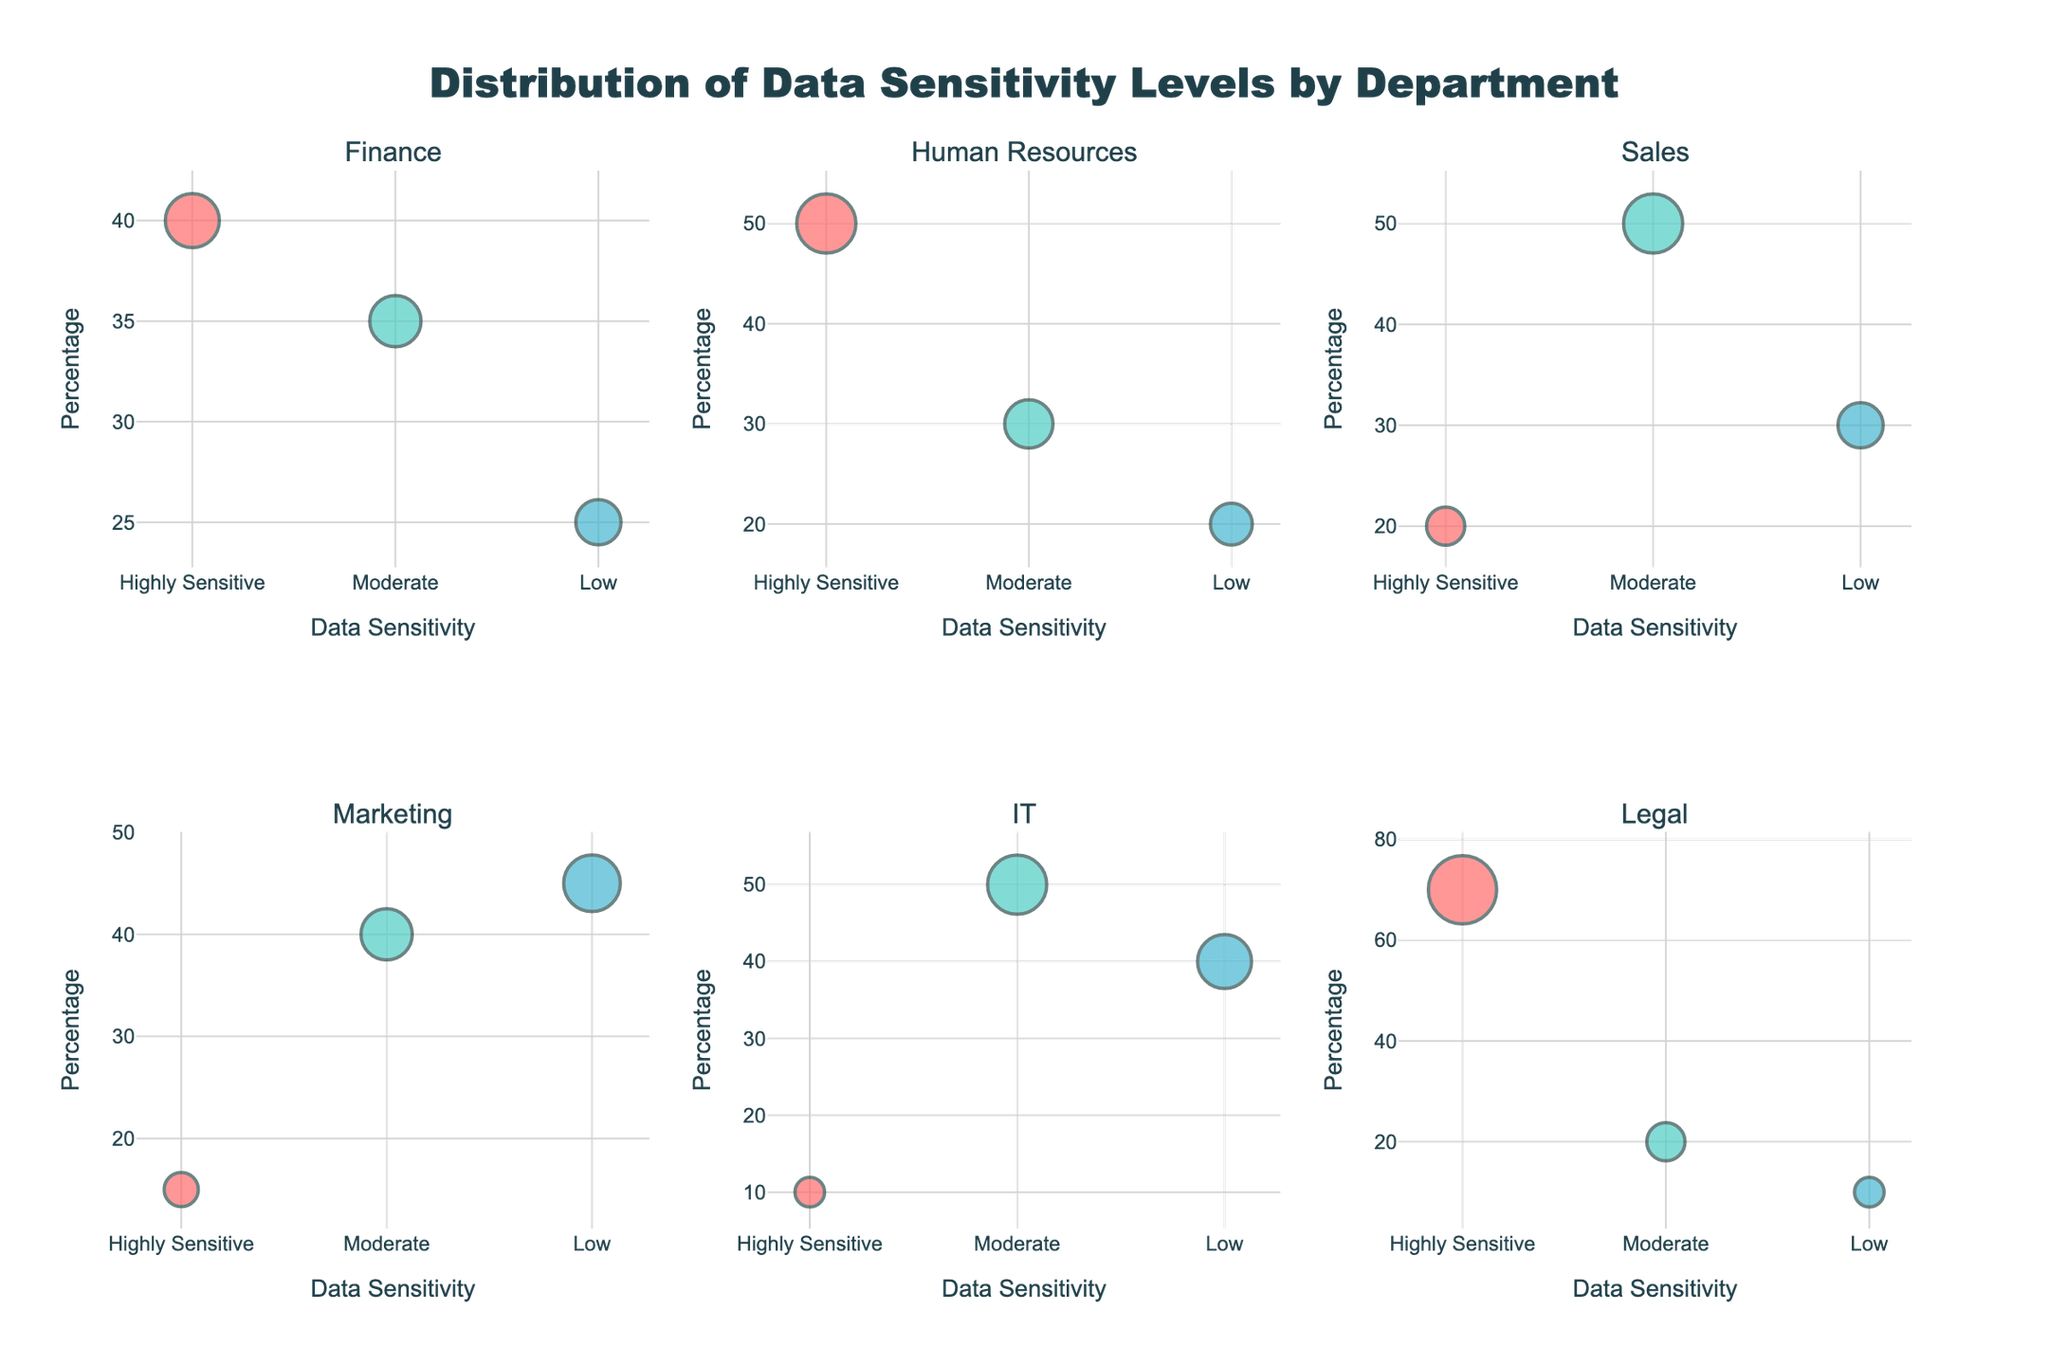What is the title of the figure? The title of the figure is displayed at the top and contains large text summarizing the subject matter.
Answer: "Distribution of Data Sensitivity Levels by Department" What is the color used for 'Highly Sensitive' data sensitivity levels? The color associated with 'Highly Sensitive' is the same across all departments and is visually distinct from other sensitivity levels.
Answer: Red Which department has the highest percentage of 'Highly Sensitive' data? Look at the department with the highest bubble in the 'Highly Sensitive' category on the y-axis.
Answer: Legal Which department has the lowest percentage of 'Highly Sensitive' data? Identifying the department with the lowest 'Highly Sensitive' bubble will show the correct department.
Answer: IT How many data points (bubbles) are plotted for each department? Each subplot (department) has three bubbles, corresponding to three data sensitivity levels. Count the bubbles.
Answer: 3 What is the total percentage of 'Moderate' data sensitivity in the IT department? Refer to the y-values of 'Moderate' for the IT department and sum it up (not necessary here since only one value exists).
Answer: 50% Which data sensitivity level is most frequent in the Sales department? Identify the category with the largest bubble size in the Sales subplot.
Answer: Moderate How does the percentage of 'Low' data sensitivity in Marketing compare to IT? Compare the y-values of 'Low' bubbles in Marketing and IT.
Answer: Marketing has a higher percentage (45% vs. 40%) What is the relationship between the count of items and bubble size? The size of the bubbles corresponds to the count of items, with larger bubbles indicating higher counts. This relationship is consistent for all subplots.
Answer: Larger bubbles indicate higher counts What department has the most balanced distribution of data sensitivity levels? Assess which department has similar-sized bubbles and more evenly spread percentages for all sensitivity levels.
Answer: Marketing 